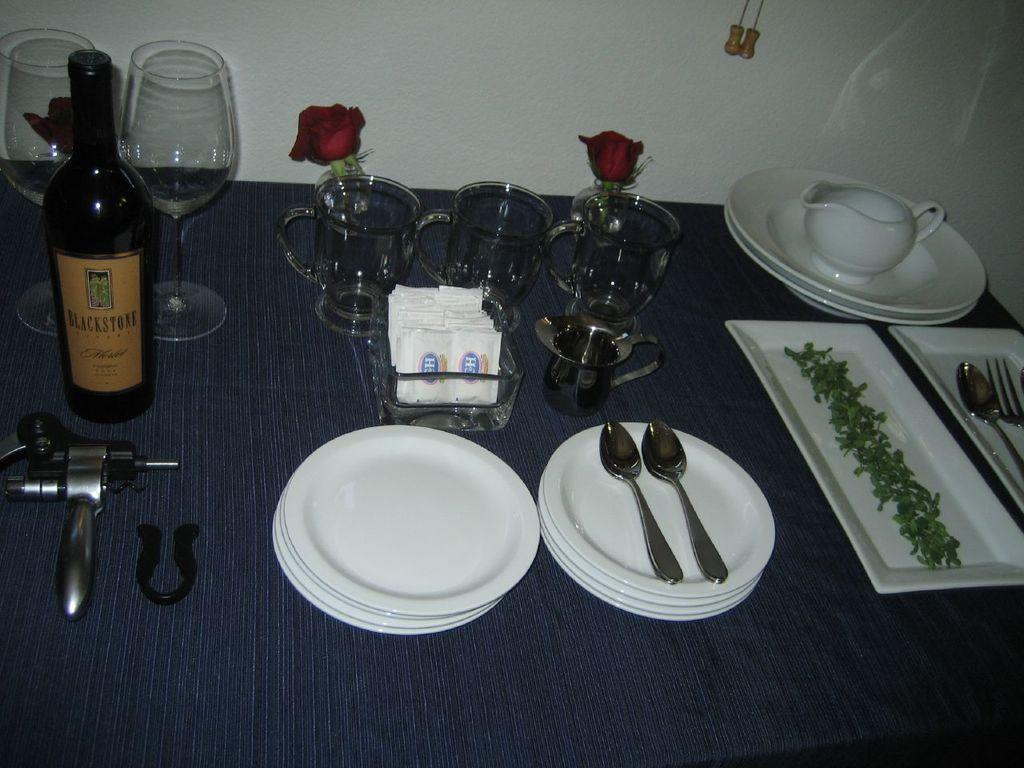What type of tableware can be seen in the image? There are plates and spoons in the image. What type of decorative item is present in the image? There is a rose flower in the image. What type of beverage is associated with the wine bottle in the image? The wine bottle in the image is associated with wine. What tool is used to open the wine bottle in the image? There is a bottle opener in the image. What type of glassware is present in the image? There are wine glasses in the image. What type of stem can be seen growing from the cup in the image? There is no cup present in the image, and therefore no stem can be seen growing from it. 